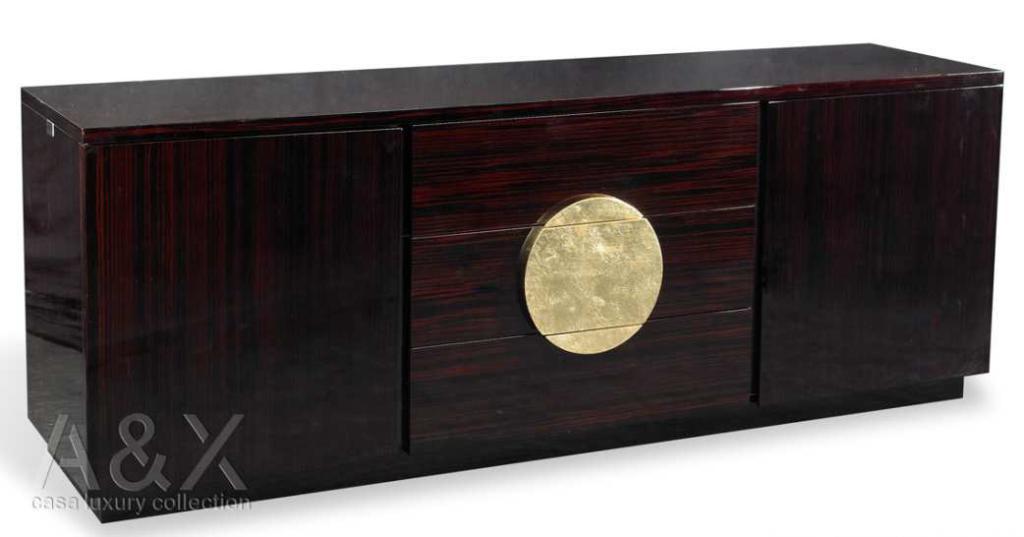Can you describe this image briefly? The picture consists of one wooden box with three shelves. 